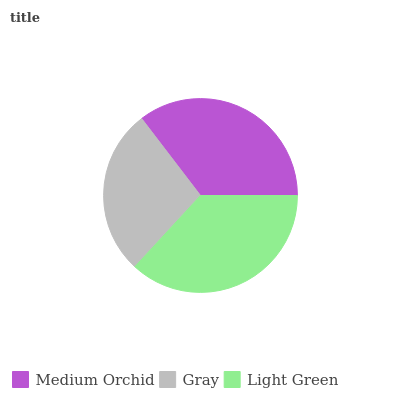Is Gray the minimum?
Answer yes or no. Yes. Is Light Green the maximum?
Answer yes or no. Yes. Is Light Green the minimum?
Answer yes or no. No. Is Gray the maximum?
Answer yes or no. No. Is Light Green greater than Gray?
Answer yes or no. Yes. Is Gray less than Light Green?
Answer yes or no. Yes. Is Gray greater than Light Green?
Answer yes or no. No. Is Light Green less than Gray?
Answer yes or no. No. Is Medium Orchid the high median?
Answer yes or no. Yes. Is Medium Orchid the low median?
Answer yes or no. Yes. Is Light Green the high median?
Answer yes or no. No. Is Gray the low median?
Answer yes or no. No. 